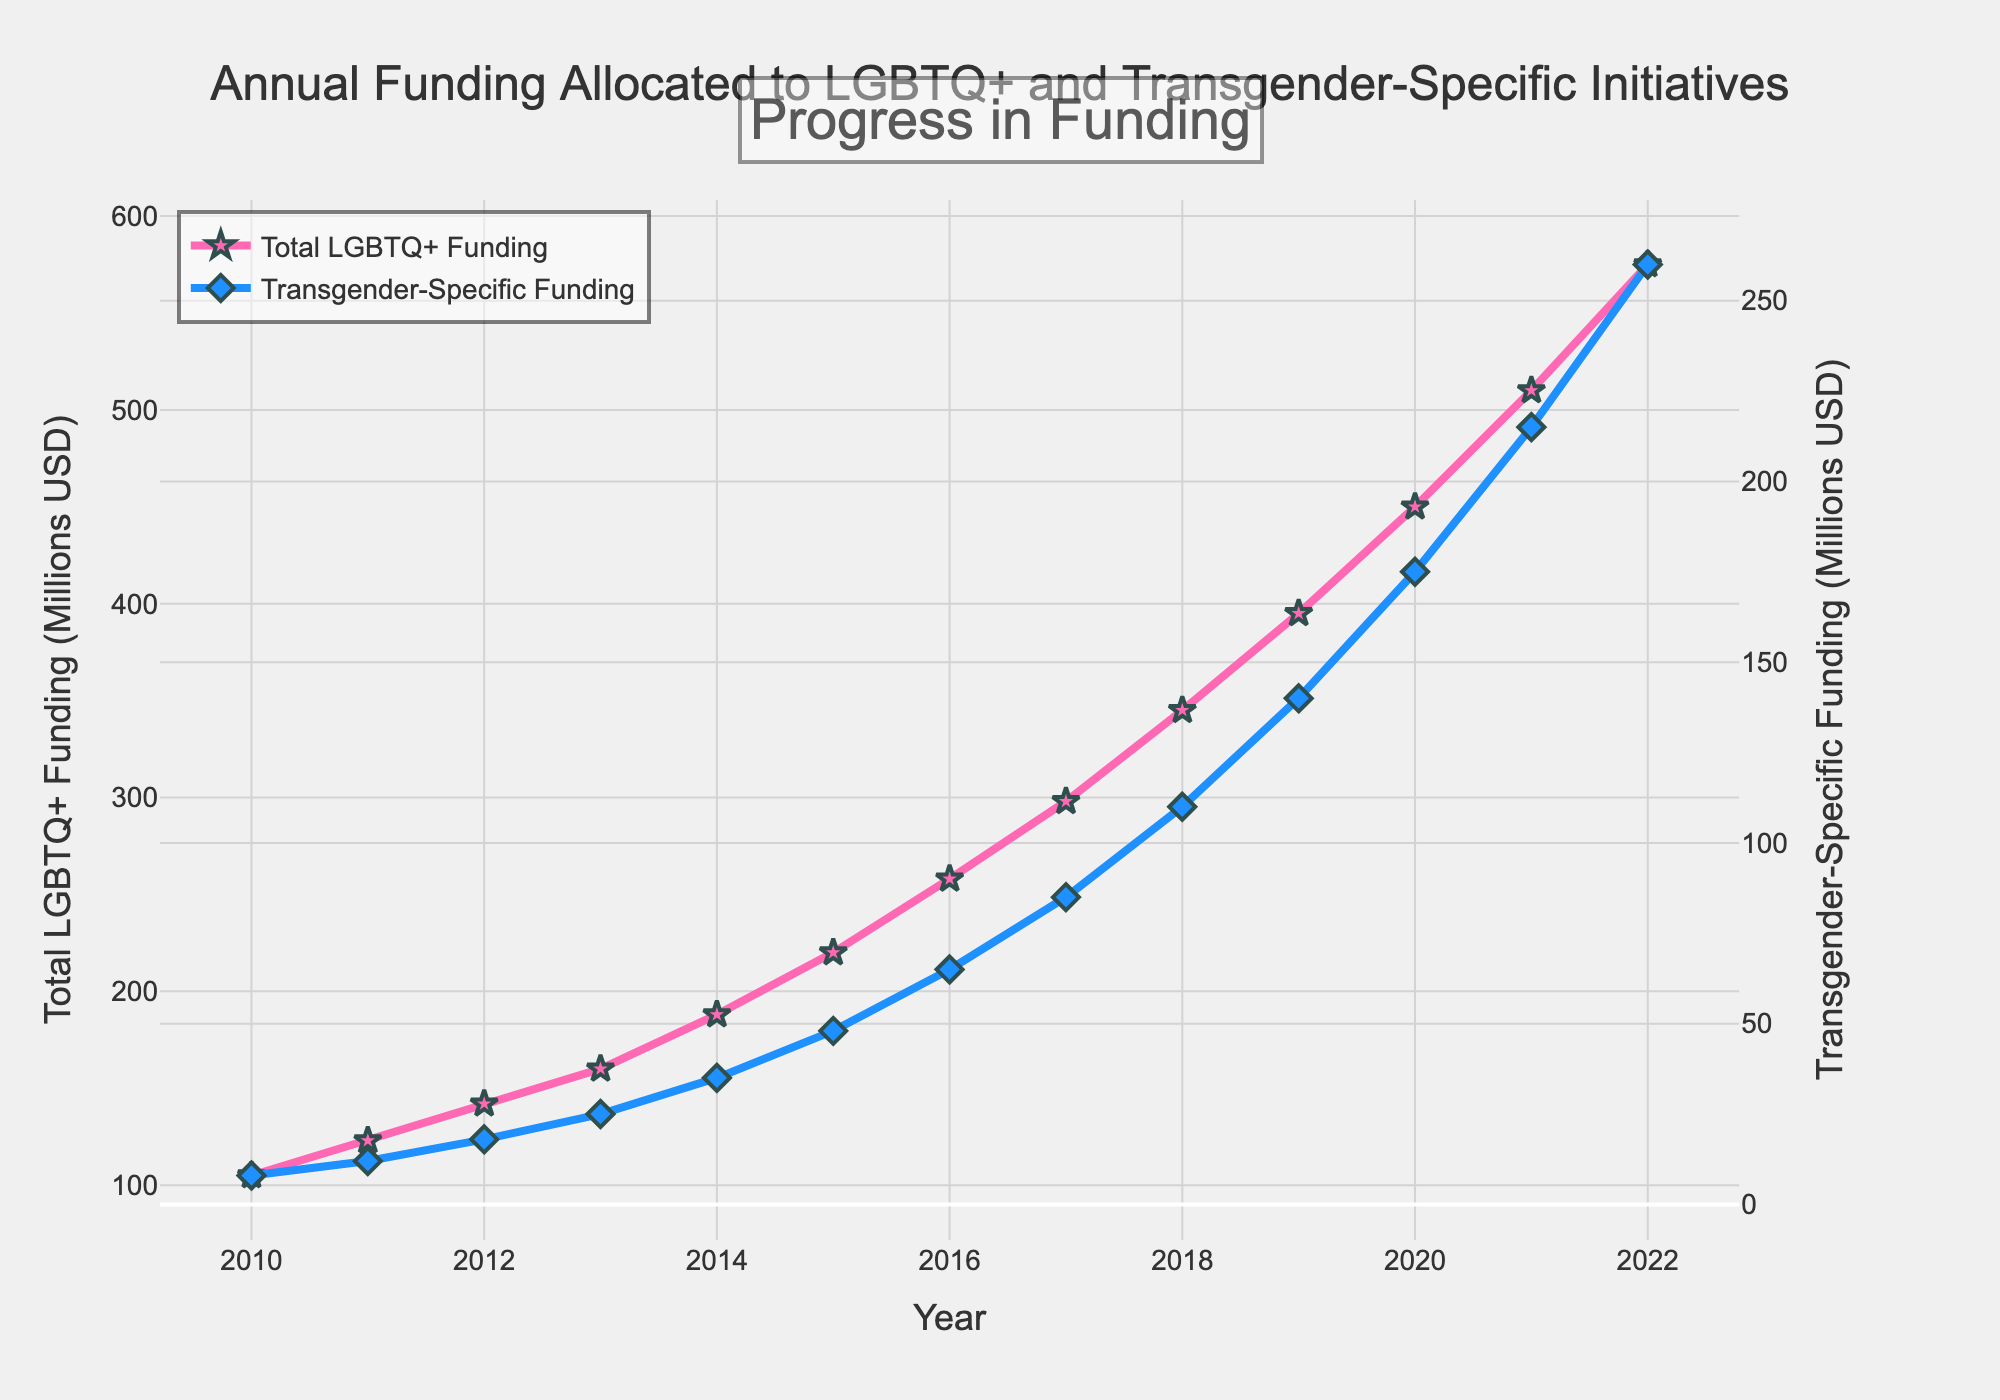What is the total amount of funding allocated to transgender-specific initiatives in 2015? Look at the data point for the year 2015 under "Transgender-Specific Funding (Millions USD)" on the line chart.
Answer: 48 million USD Which year shows the highest difference between Total LGBTQ+ Funding and Transgender-Specific Funding? To find the highest difference, calculate the difference between the two funding sources for each year and determine which year has the maximum value.
Answer: 2022 By how much did the Transgender-Specific Funding increase from 2010 to 2022? Subtract the 2010 Transgender-Specific Funding value from the 2022 Transgender-Specific Funding value: 260 - 8 = 252 million USD.
Answer: 252 million USD Which year saw the highest percentage increase in Transgender-Specific Funding compared to the previous year? Calculate the percentage increase [(current year - previous year) / previous year * 100] for each year and compare. It increased the most from 2014 to 2015: [(48 - 35) / 35 * 100] = 37.14%.
Answer: 2015 Is the slope of the Transgender-Specific Funding line steeper in the early years or later years of the plot? Examine the visual gradient of the Transgender-Specific Funding line; it is steeper in the later years (2017-2022) compared to the early years (2010-2013).
Answer: Later years What was the approximate funding allocated to Total LGBTQ+ organizations in the year when Transgender-Specific Funding reached 100 million USD? Identify the year when Transgender-Specific Funding reached 110 million USD (2018) and then check the corresponding Total LGBTQ+ Funding value.
Answer: 345 million USD Estimate the percentage share of Transgender-Specific Funding in the Total LGBTQ+ Funding in 2020. Divide the Transgender-Specific Funding by Total LGBTQ+ Funding for 2020 and multiply by 100: (175 / 450) * 100.
Answer: 38.89% What is the trend observed in both Total LGBTQ+ Funding and Transgender-Specific Funding? Identify that both lines are trending upward consistently over the years from 2010 to 2022, indicating increasing funding.
Answer: Increasing trend Given the trend, predict the funding for Transgender-Specific initiatives in 2023 if the funding continues to grow at the same rate as 2021-2022. Calculate the growth from 2021 to 2022 (260 - 215 = 45) and add to the 2022 value: 260 + 45 = 305 million USD.
Answer: 305 million USD Why might the Total LGBTQ+ Funding line be offset significantly higher than the Transgender-Specific Funding line? Because Total LGBTQ+ Funding encompasses a broader range of initiatives beyond just transgender-specific ones, leading to higher overall funding.
Answer: Broader range of initiatives 